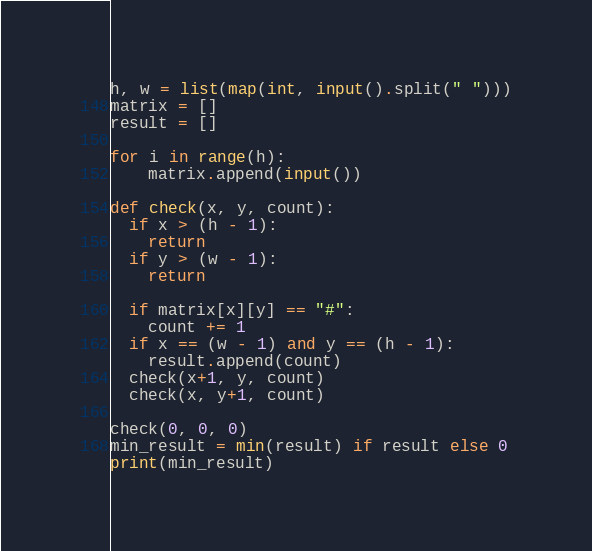Convert code to text. <code><loc_0><loc_0><loc_500><loc_500><_Python_>h, w = list(map(int, input().split(" ")))
matrix = []
result = []

for i in range(h):
    matrix.append(input())
    
def check(x, y, count):
  if x > (h - 1):
    return
  if y > (w - 1):
    return

  if matrix[x][y] == "#":
    count += 1
  if x == (w - 1) and y == (h - 1):
    result.append(count)
  check(x+1, y, count)
  check(x, y+1, count)

check(0, 0, 0)
min_result = min(result) if result else 0
print(min_result)
</code> 